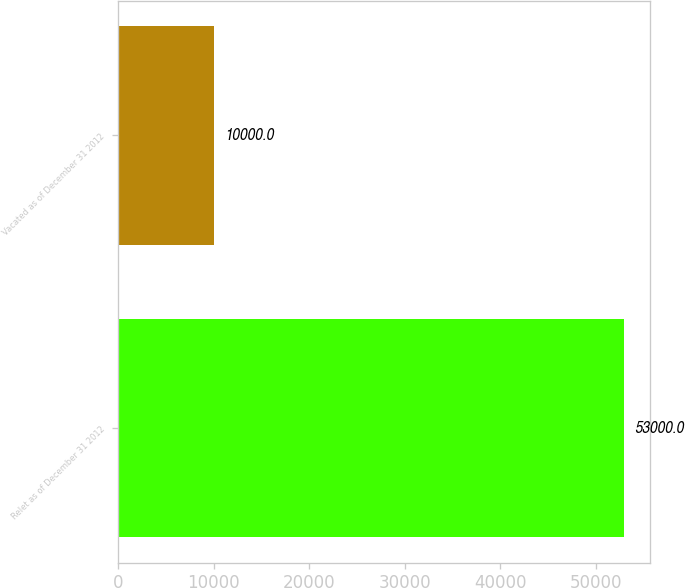<chart> <loc_0><loc_0><loc_500><loc_500><bar_chart><fcel>Relet as of December 31 2012<fcel>Vacated as of December 31 2012<nl><fcel>53000<fcel>10000<nl></chart> 